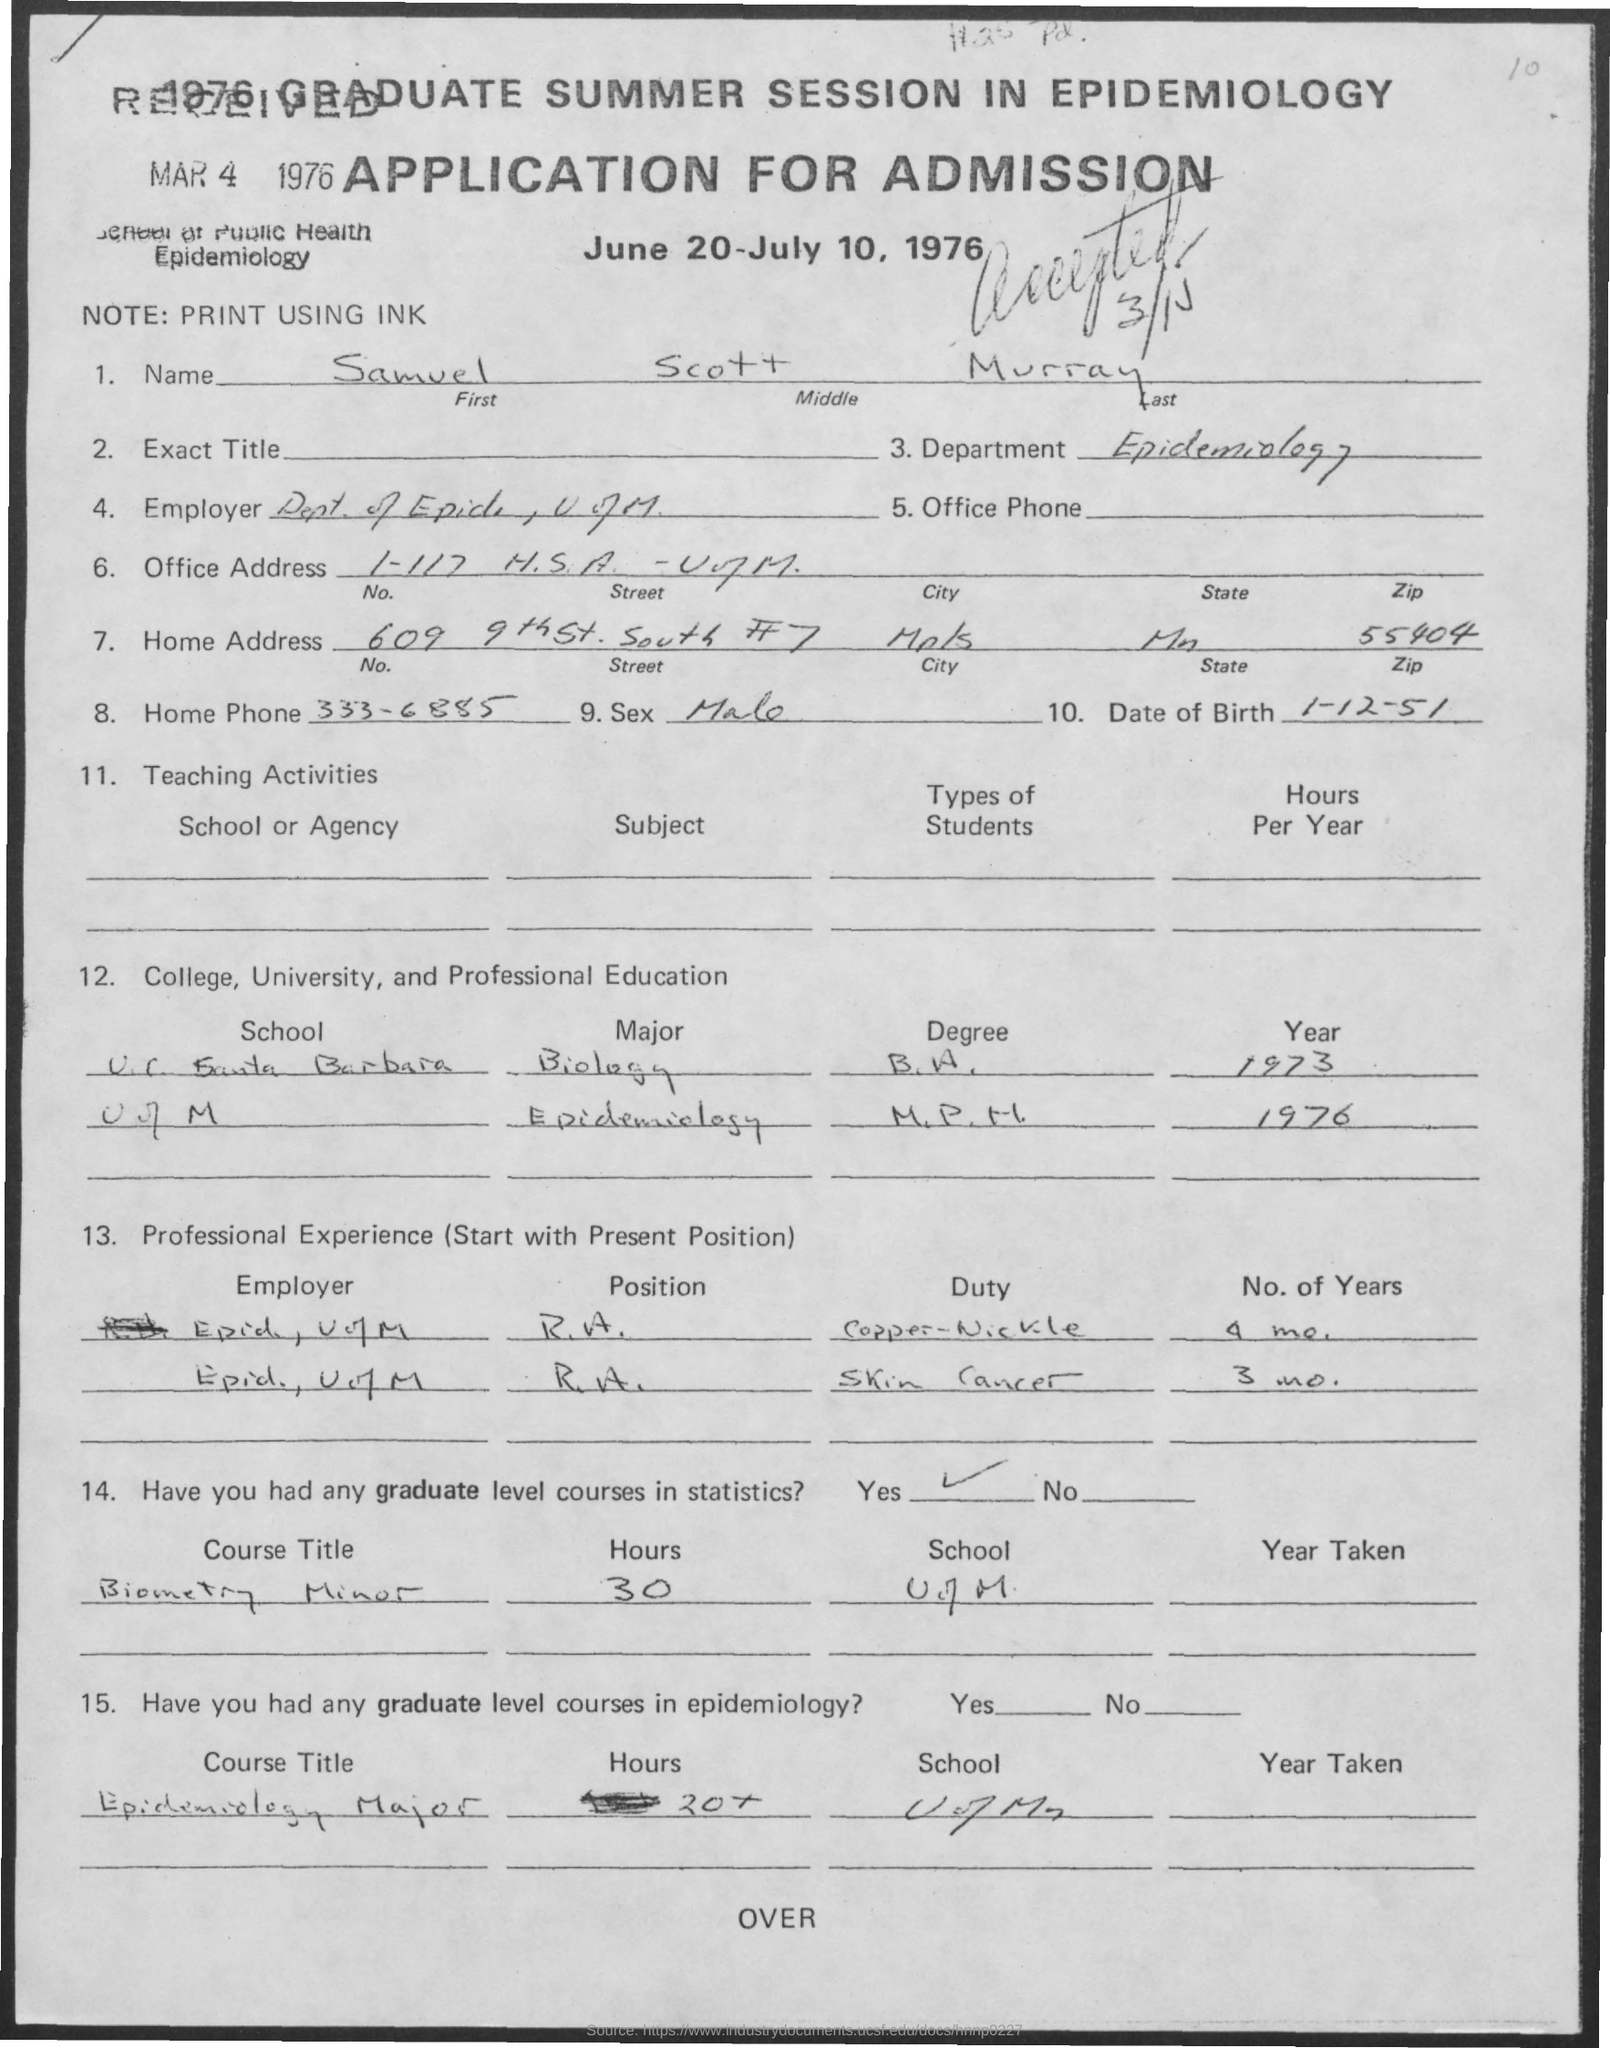Identify some key points in this picture. The date of Samuel's birth is December 1, 1951. The name of the person who applied is Samuel Scott Murray. I, [Your Name], am applying for admission to [Program/Institution Name]. Samuel worked on skin cancer for a total of 3 months. Samuel has a graduate-level course in statistics. 